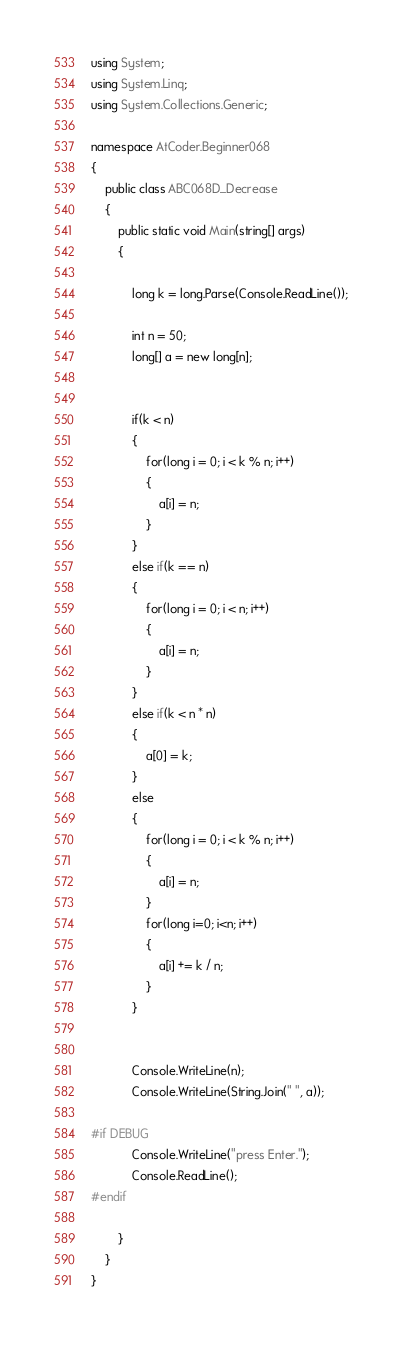Convert code to text. <code><loc_0><loc_0><loc_500><loc_500><_C#_>using System;
using System.Linq;
using System.Collections.Generic;

namespace AtCoder.Beginner068
{
    public class ABC068D_Decrease
    {
        public static void Main(string[] args)
        {

            long k = long.Parse(Console.ReadLine());

            int n = 50;
            long[] a = new long[n];


            if(k < n)
            {
                for(long i = 0; i < k % n; i++)
                {
                    a[i] = n;
                }
            }
            else if(k == n)
            {
                for(long i = 0; i < n; i++)
                {
                    a[i] = n;
                }
            }
            else if(k < n * n)
            {
                a[0] = k;
            }
            else
            {
                for(long i = 0; i < k % n; i++)
                {
                    a[i] = n;
                }
                for(long i=0; i<n; i++)
                {
                    a[i] += k / n;
                }
            }


            Console.WriteLine(n);
            Console.WriteLine(String.Join(" ", a));

#if DEBUG
            Console.WriteLine("press Enter.");
            Console.ReadLine();
#endif

        }
    }
}</code> 